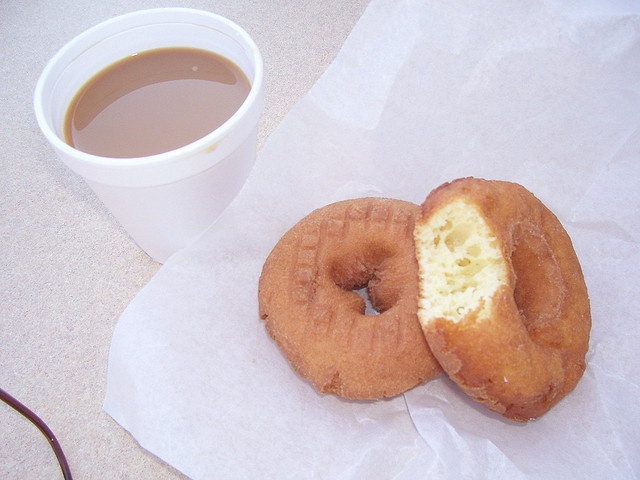Describe the objects in this image and their specific colors. I can see dining table in lavender, lightgray, and darkgray tones, cup in lavender, darkgray, and gray tones, donut in lavender, salmon, tan, and beige tones, and donut in lavender, salmon, and tan tones in this image. 